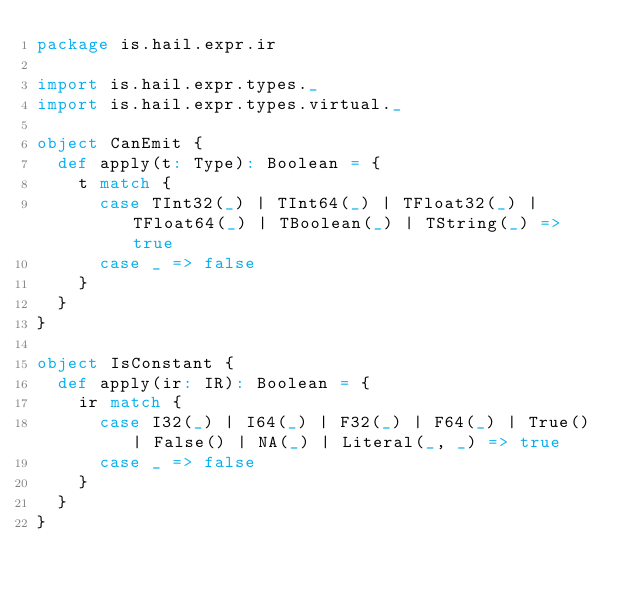<code> <loc_0><loc_0><loc_500><loc_500><_Scala_>package is.hail.expr.ir

import is.hail.expr.types._
import is.hail.expr.types.virtual._

object CanEmit {
  def apply(t: Type): Boolean = {
    t match {
      case TInt32(_) | TInt64(_) | TFloat32(_) | TFloat64(_) | TBoolean(_) | TString(_) => true
      case _ => false
    }
  }
}

object IsConstant {
  def apply(ir: IR): Boolean = {
    ir match {
      case I32(_) | I64(_) | F32(_) | F64(_) | True() | False() | NA(_) | Literal(_, _) => true
      case _ => false
    }
  }
}
</code> 